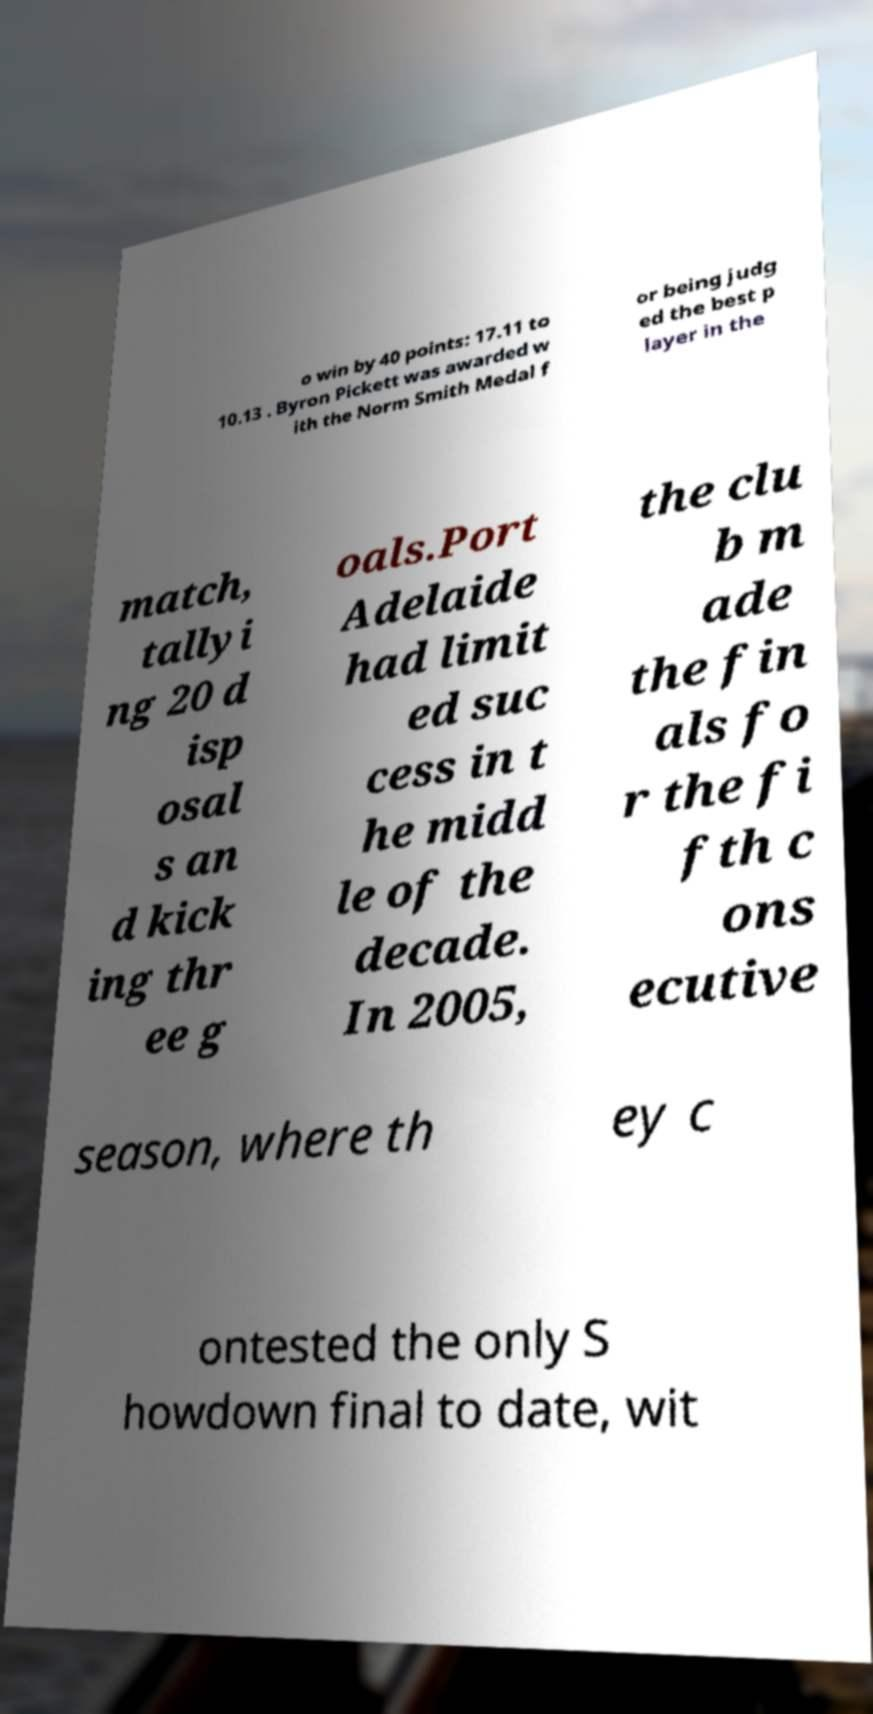For documentation purposes, I need the text within this image transcribed. Could you provide that? o win by 40 points: 17.11 to 10.13 . Byron Pickett was awarded w ith the Norm Smith Medal f or being judg ed the best p layer in the match, tallyi ng 20 d isp osal s an d kick ing thr ee g oals.Port Adelaide had limit ed suc cess in t he midd le of the decade. In 2005, the clu b m ade the fin als fo r the fi fth c ons ecutive season, where th ey c ontested the only S howdown final to date, wit 